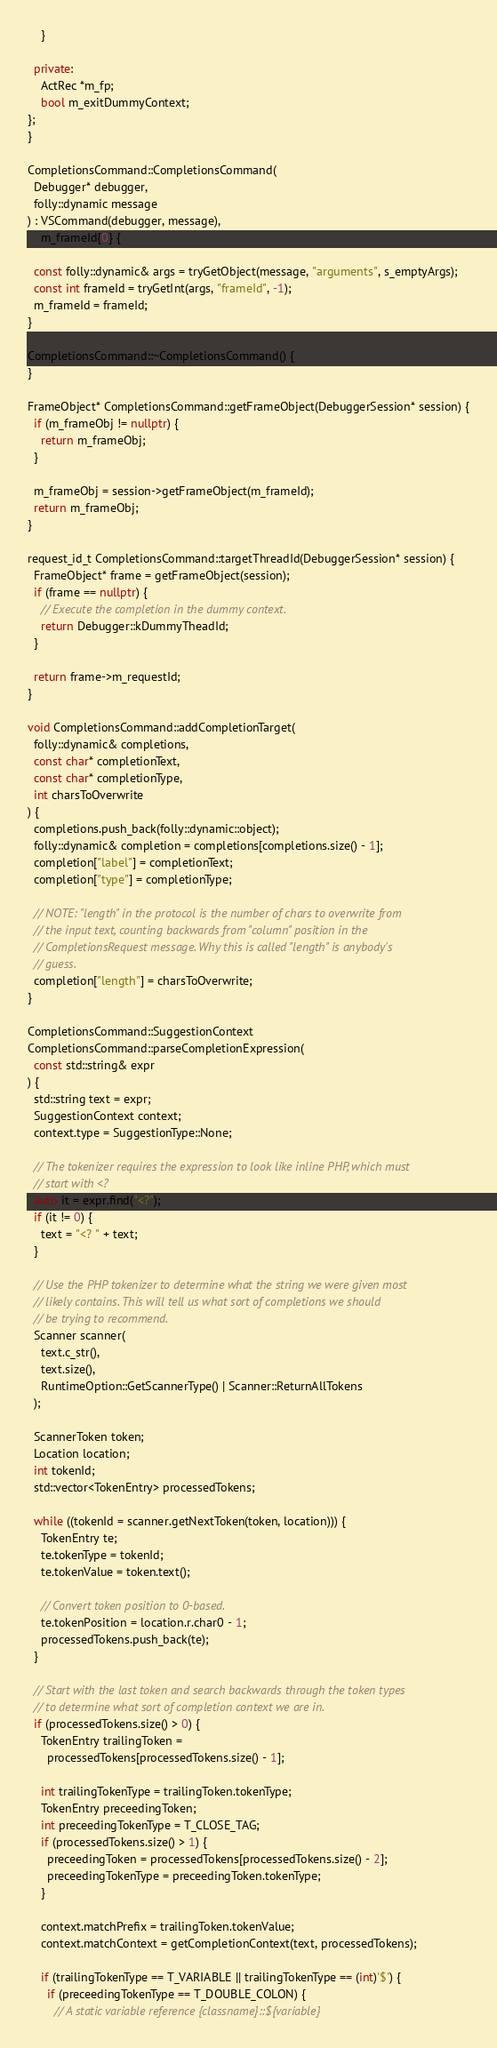Convert code to text. <code><loc_0><loc_0><loc_500><loc_500><_C++_>    }

  private:
    ActRec *m_fp;
    bool m_exitDummyContext;
};
}

CompletionsCommand::CompletionsCommand(
  Debugger* debugger,
  folly::dynamic message
) : VSCommand(debugger, message),
    m_frameId{0} {

  const folly::dynamic& args = tryGetObject(message, "arguments", s_emptyArgs);
  const int frameId = tryGetInt(args, "frameId", -1);
  m_frameId = frameId;
}

CompletionsCommand::~CompletionsCommand() {
}

FrameObject* CompletionsCommand::getFrameObject(DebuggerSession* session) {
  if (m_frameObj != nullptr) {
    return m_frameObj;
  }

  m_frameObj = session->getFrameObject(m_frameId);
  return m_frameObj;
}

request_id_t CompletionsCommand::targetThreadId(DebuggerSession* session) {
  FrameObject* frame = getFrameObject(session);
  if (frame == nullptr) {
    // Execute the completion in the dummy context.
    return Debugger::kDummyTheadId;
  }

  return frame->m_requestId;
}

void CompletionsCommand::addCompletionTarget(
  folly::dynamic& completions,
  const char* completionText,
  const char* completionType,
  int charsToOverwrite
) {
  completions.push_back(folly::dynamic::object);
  folly::dynamic& completion = completions[completions.size() - 1];
  completion["label"] = completionText;
  completion["type"] = completionType;

  // NOTE: "length" in the protocol is the number of chars to overwrite from
  // the input text, counting backwards from "column" position in the
  // CompletionsRequest message. Why this is called "length" is anybody's
  // guess.
  completion["length"] = charsToOverwrite;
}

CompletionsCommand::SuggestionContext
CompletionsCommand::parseCompletionExpression(
  const std::string& expr
) {
  std::string text = expr;
  SuggestionContext context;
  context.type = SuggestionType::None;

  // The tokenizer requires the expression to look like inline PHP, which must
  // start with <?
  auto it = expr.find("<?");
  if (it != 0) {
    text = "<? " + text;
  }

  // Use the PHP tokenizer to determine what the string we were given most
  // likely contains. This will tell us what sort of completions we should
  // be trying to recommend.
  Scanner scanner(
    text.c_str(),
    text.size(),
    RuntimeOption::GetScannerType() | Scanner::ReturnAllTokens
  );

  ScannerToken token;
  Location location;
  int tokenId;
  std::vector<TokenEntry> processedTokens;

  while ((tokenId = scanner.getNextToken(token, location))) {
    TokenEntry te;
    te.tokenType = tokenId;
    te.tokenValue = token.text();

    // Convert token position to 0-based.
    te.tokenPosition = location.r.char0 - 1;
    processedTokens.push_back(te);
  }

  // Start with the last token and search backwards through the token types
  // to determine what sort of completion context we are in.
  if (processedTokens.size() > 0) {
    TokenEntry trailingToken =
      processedTokens[processedTokens.size() - 1];

    int trailingTokenType = trailingToken.tokenType;
    TokenEntry preceedingToken;
    int preceedingTokenType = T_CLOSE_TAG;
    if (processedTokens.size() > 1) {
      preceedingToken = processedTokens[processedTokens.size() - 2];
      preceedingTokenType = preceedingToken.tokenType;
    }

    context.matchPrefix = trailingToken.tokenValue;
    context.matchContext = getCompletionContext(text, processedTokens);

    if (trailingTokenType == T_VARIABLE || trailingTokenType == (int)'$') {
      if (preceedingTokenType == T_DOUBLE_COLON) {
        // A static variable reference {classname}::${variable}</code> 